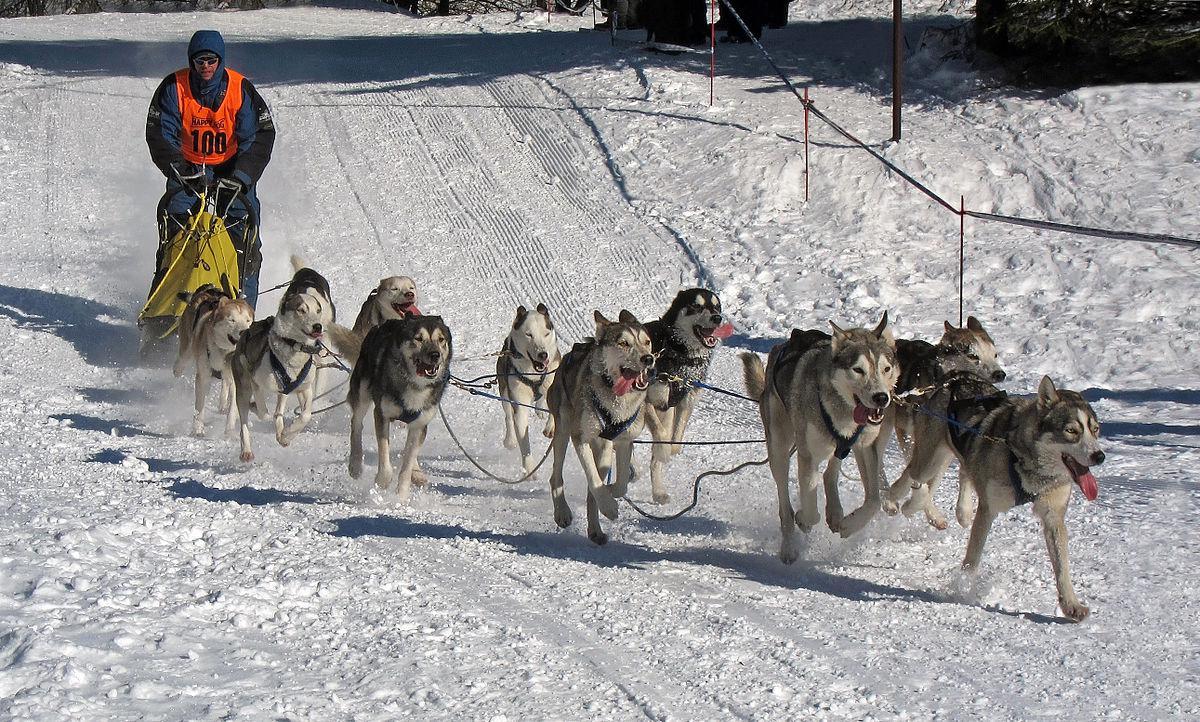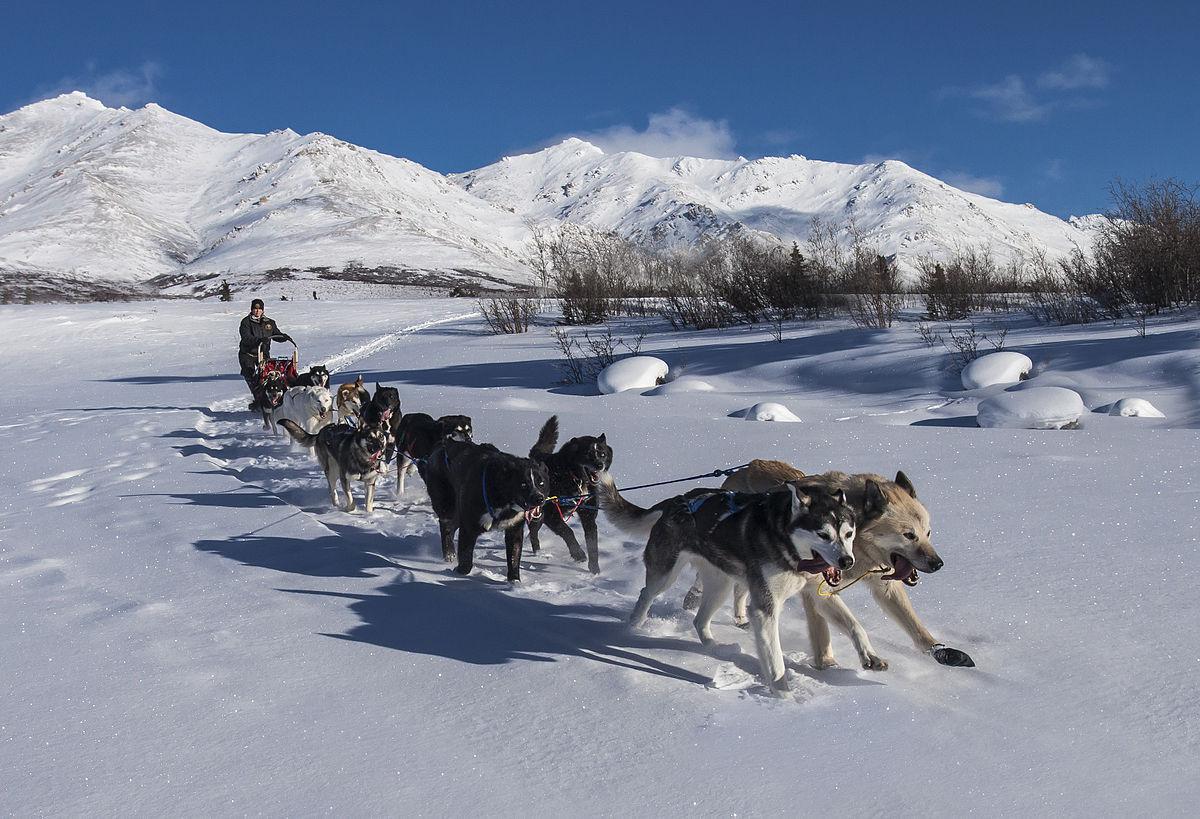The first image is the image on the left, the second image is the image on the right. Assess this claim about the two images: "An SUV can be seen in the background on at least one of the images.". Correct or not? Answer yes or no. No. The first image is the image on the left, the second image is the image on the right. Examine the images to the left and right. Is the description "The exterior of a motorized vehicle is visible behind sled dogs in at least one image." accurate? Answer yes or no. No. 